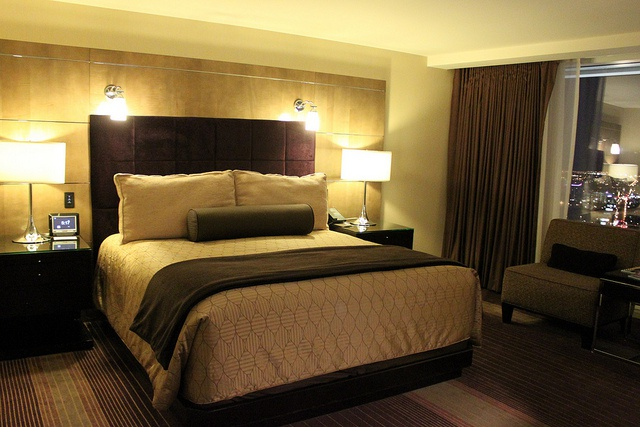Describe the objects in this image and their specific colors. I can see bed in khaki, black, maroon, and olive tones, chair in khaki, black, and olive tones, and clock in khaki, gray, and ivory tones in this image. 